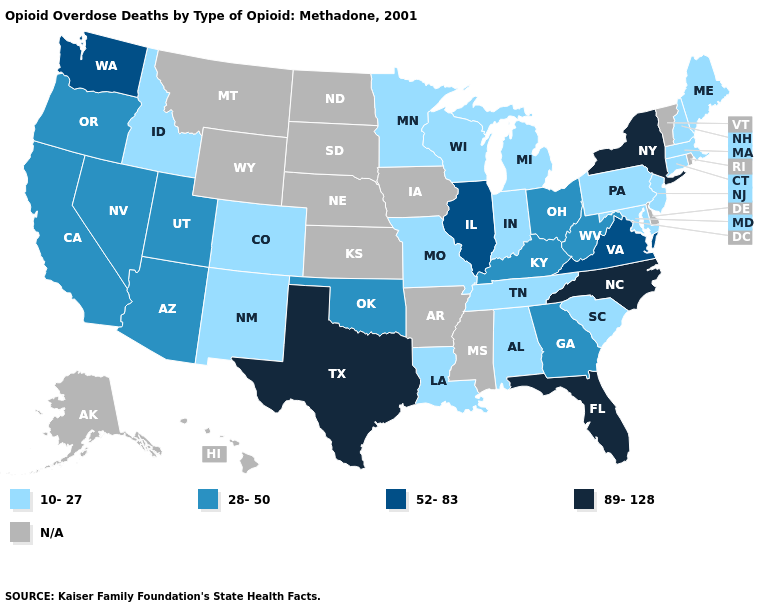Name the states that have a value in the range N/A?
Keep it brief. Alaska, Arkansas, Delaware, Hawaii, Iowa, Kansas, Mississippi, Montana, Nebraska, North Dakota, Rhode Island, South Dakota, Vermont, Wyoming. Name the states that have a value in the range N/A?
Concise answer only. Alaska, Arkansas, Delaware, Hawaii, Iowa, Kansas, Mississippi, Montana, Nebraska, North Dakota, Rhode Island, South Dakota, Vermont, Wyoming. What is the lowest value in states that border North Carolina?
Write a very short answer. 10-27. Name the states that have a value in the range 28-50?
Write a very short answer. Arizona, California, Georgia, Kentucky, Nevada, Ohio, Oklahoma, Oregon, Utah, West Virginia. What is the highest value in the USA?
Concise answer only. 89-128. What is the value of Georgia?
Answer briefly. 28-50. What is the highest value in the USA?
Answer briefly. 89-128. What is the highest value in states that border Idaho?
Write a very short answer. 52-83. Which states have the lowest value in the USA?
Write a very short answer. Alabama, Colorado, Connecticut, Idaho, Indiana, Louisiana, Maine, Maryland, Massachusetts, Michigan, Minnesota, Missouri, New Hampshire, New Jersey, New Mexico, Pennsylvania, South Carolina, Tennessee, Wisconsin. Does the first symbol in the legend represent the smallest category?
Answer briefly. Yes. What is the value of Pennsylvania?
Quick response, please. 10-27. What is the value of Pennsylvania?
Answer briefly. 10-27. What is the highest value in the Northeast ?
Write a very short answer. 89-128. What is the value of Rhode Island?
Be succinct. N/A. Which states have the highest value in the USA?
Concise answer only. Florida, New York, North Carolina, Texas. 